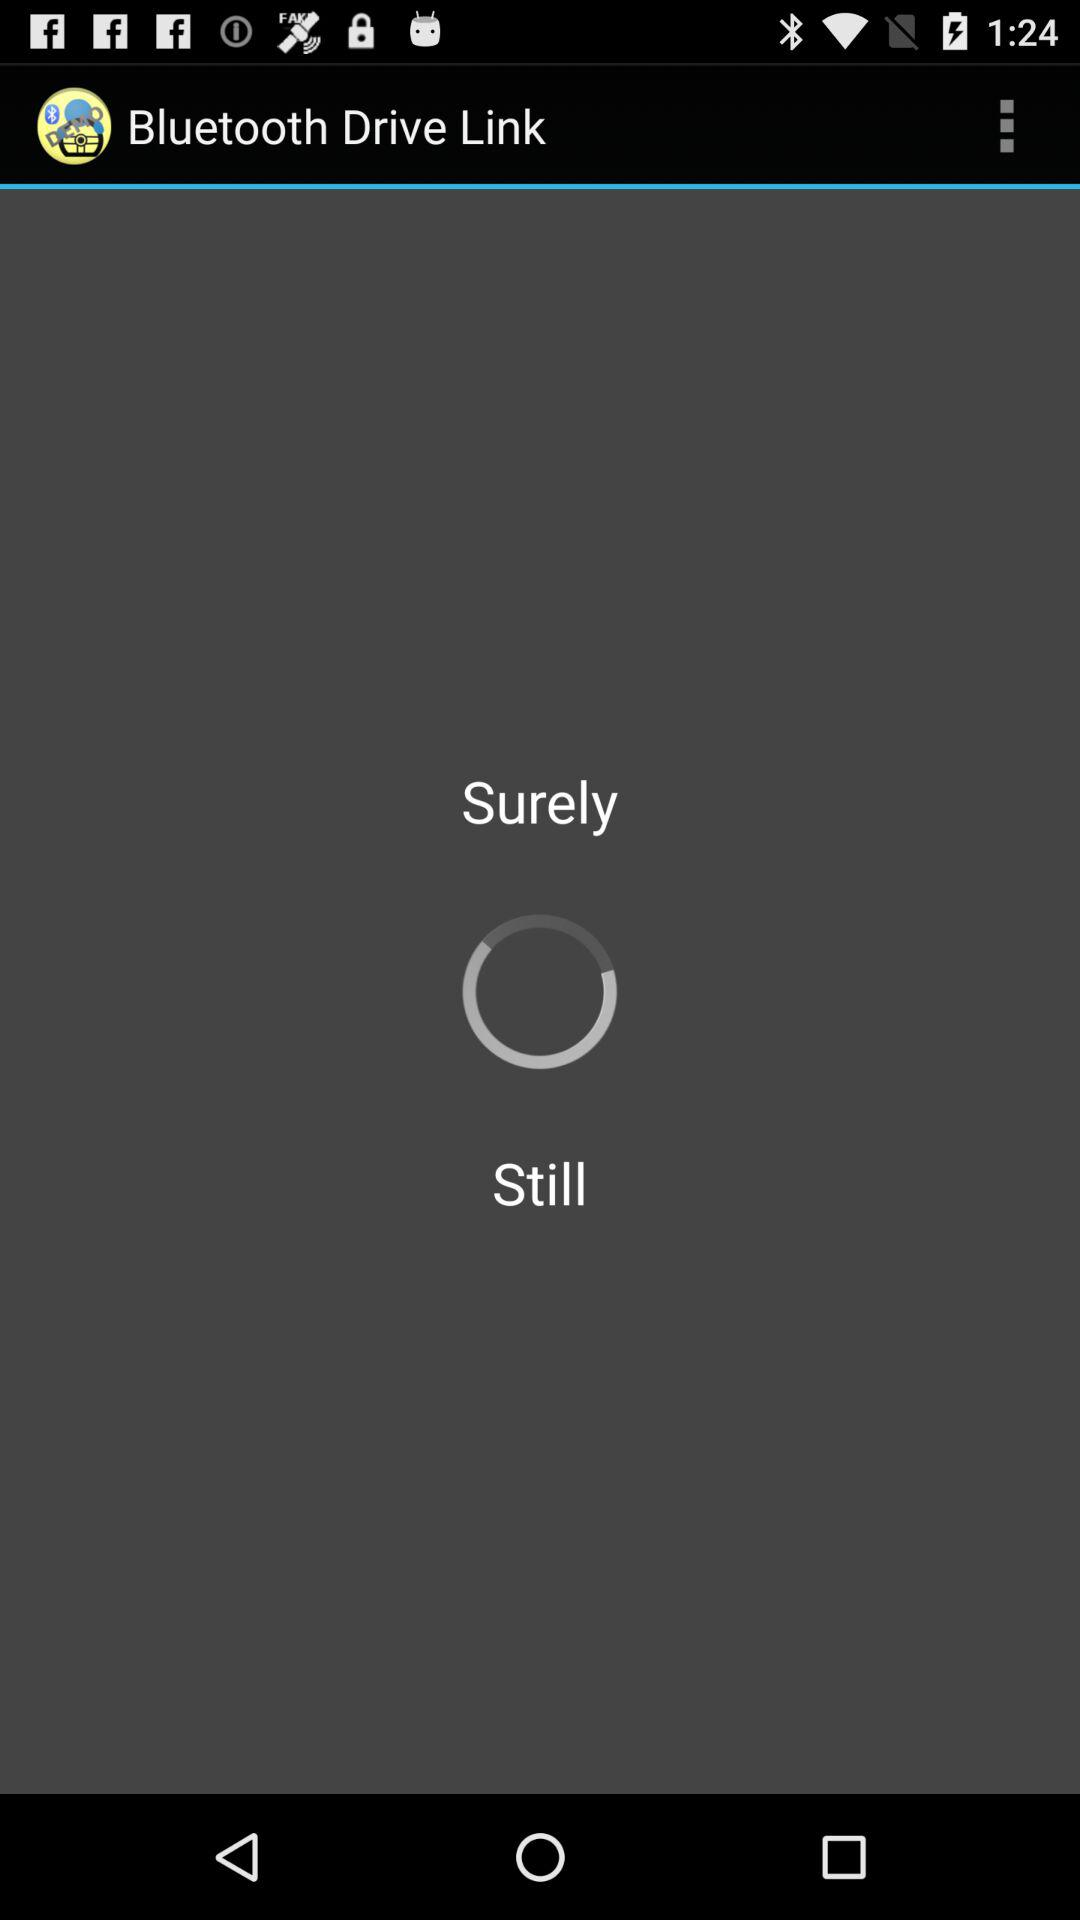What is the application name? The application name is "Bluetooth Drive Link". 